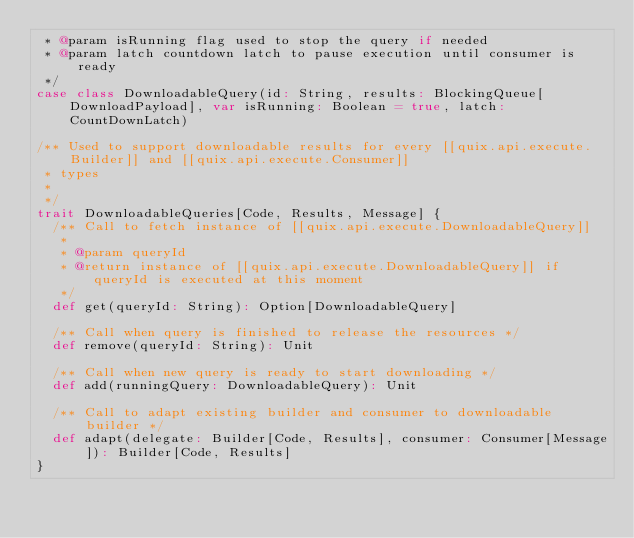<code> <loc_0><loc_0><loc_500><loc_500><_Scala_> * @param isRunning flag used to stop the query if needed
 * @param latch countdown latch to pause execution until consumer is ready
 */
case class DownloadableQuery(id: String, results: BlockingQueue[DownloadPayload], var isRunning: Boolean = true, latch: CountDownLatch)

/** Used to support downloadable results for every [[quix.api.execute.Builder]] and [[quix.api.execute.Consumer]]
 * types
 *
 */
trait DownloadableQueries[Code, Results, Message] {
  /** Call to fetch instance of [[quix.api.execute.DownloadableQuery]]
   *
   * @param queryId
   * @return instance of [[quix.api.execute.DownloadableQuery]] if queryId is executed at this moment
   */
  def get(queryId: String): Option[DownloadableQuery]

  /** Call when query is finished to release the resources */
  def remove(queryId: String): Unit

  /** Call when new query is ready to start downloading */
  def add(runningQuery: DownloadableQuery): Unit

  /** Call to adapt existing builder and consumer to downloadable builder */
  def adapt(delegate: Builder[Code, Results], consumer: Consumer[Message]): Builder[Code, Results]
}


</code> 